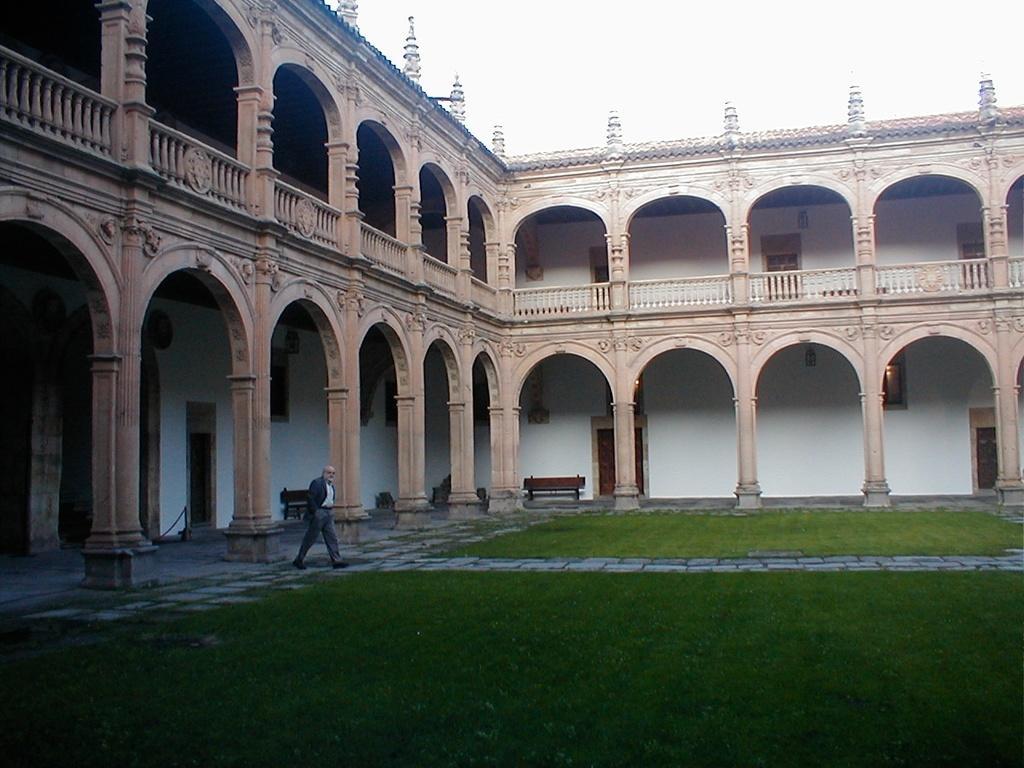How would you summarize this image in a sentence or two? In this image I can see the ground, some grass on the ground, a person wearing black blazer, white shirt and grey pant is standing on the ground. I can see the building which is cream and white in color, a bench, few windows of the building and few doors. In the background I can see the sky. 